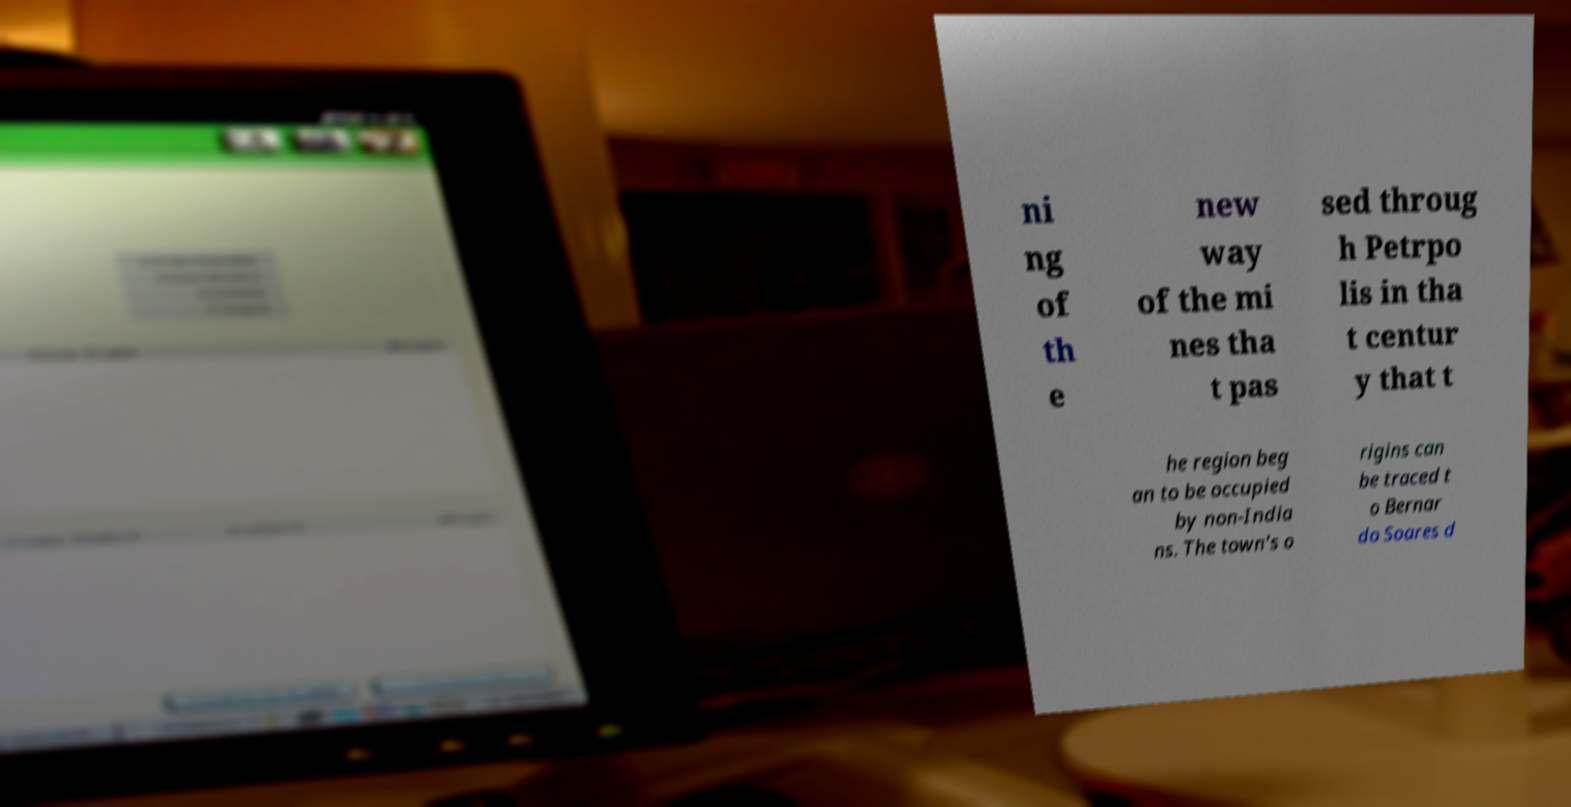Can you read and provide the text displayed in the image?This photo seems to have some interesting text. Can you extract and type it out for me? ni ng of th e new way of the mi nes tha t pas sed throug h Petrpo lis in tha t centur y that t he region beg an to be occupied by non-India ns. The town's o rigins can be traced t o Bernar do Soares d 